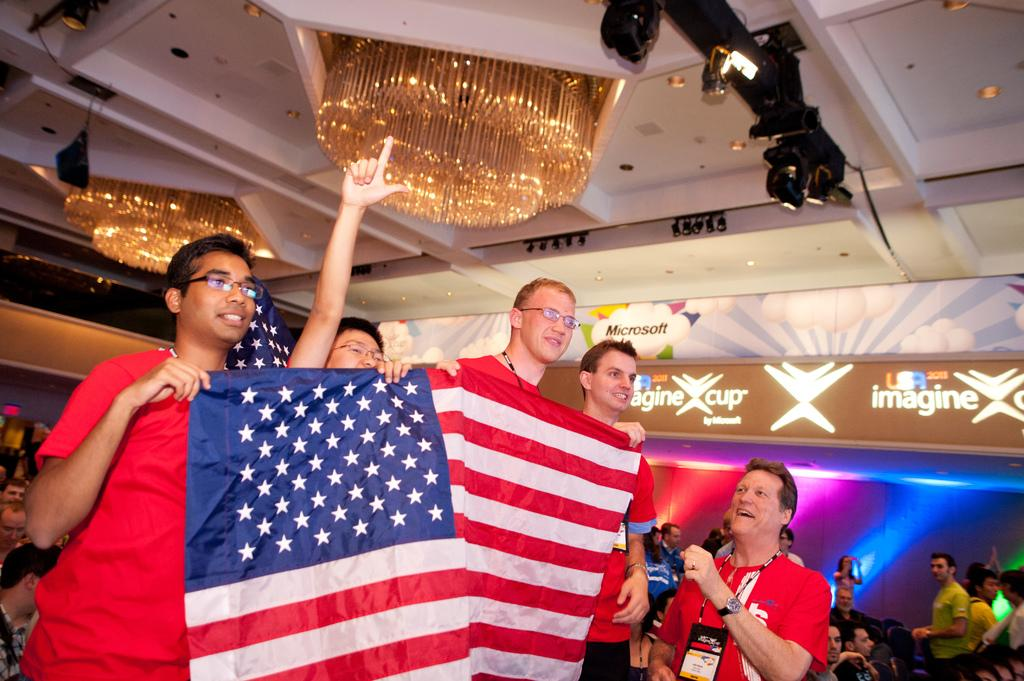What are the people in the image doing with the flags? The people in the image are standing and holding flags. What are the people in the image doing besides holding flags? There are people sitting in the image. What objects can be seen in the image besides people and flags? There are boards visible in the image. What type of lighting is present in the image? Different color lights are present in the image. What type of wire is being used by the person's dad in the image? There is no mention of a dad or wire in the image; the facts provided only mention people holding flags, people sitting, and the presence of boards and different color lights. 